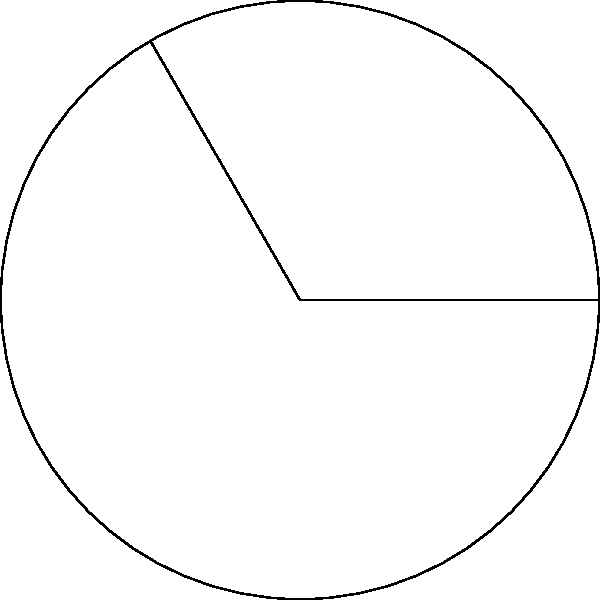In your latest novel, you've described a circular garden with a central fountain. A sector of this garden is dedicated to a specific type of flower. If the radius of the garden is 9 meters and the central angle of this sector is $120°$, what is the area of the flower-dedicated sector? Round your answer to two decimal places. Let's approach this step-by-step:

1) The formula for the area of a circular sector is:

   $$A = \frac{\theta}{360°} \cdot \pi r^2$$

   Where $\theta$ is the central angle in degrees, and $r$ is the radius.

2) We're given:
   - Radius ($r$) = 9 meters
   - Central angle ($\theta$) = $120°$

3) Let's substitute these values into our formula:

   $$A = \frac{120°}{360°} \cdot \pi \cdot 9^2$$

4) Simplify:
   $$A = \frac{1}{3} \cdot \pi \cdot 81$$

5) Calculate:
   $$A = 27\pi$$

6) Use $\pi \approx 3.14159$:
   $$A \approx 27 \cdot 3.14159 = 84.82293$$

7) Rounding to two decimal places:
   $$A \approx 84.82 \text{ square meters}$$
Answer: $84.82 \text{ m}^2$ 